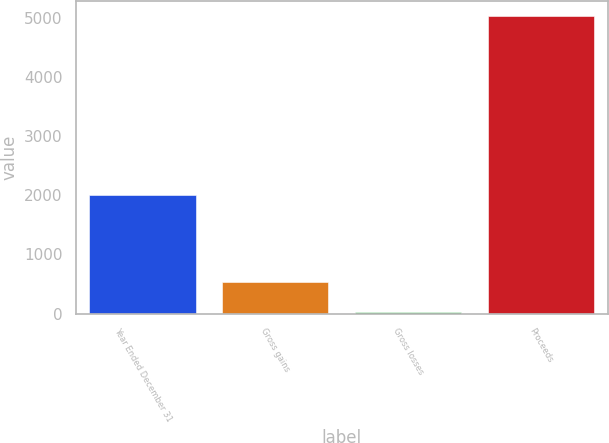<chart> <loc_0><loc_0><loc_500><loc_500><bar_chart><fcel>Year Ended December 31<fcel>Gross gains<fcel>Gross losses<fcel>Proceeds<nl><fcel>2012<fcel>535.1<fcel>35<fcel>5036<nl></chart> 